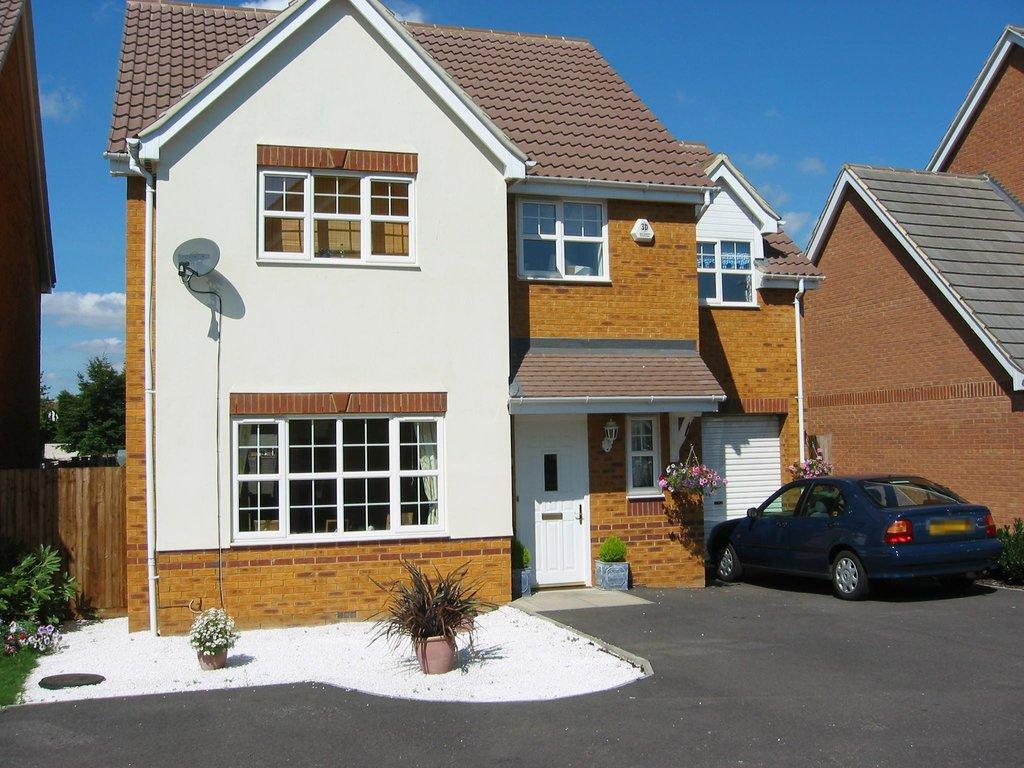Describe this image in one or two sentences. This is a front view of a building, in this image we can see a car parked in front of the house and there are few plants. 